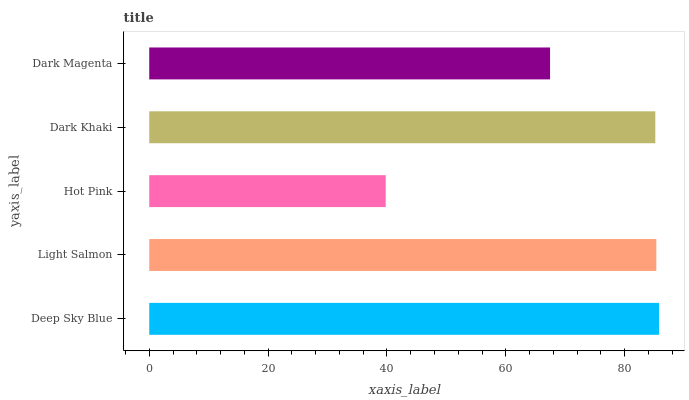Is Hot Pink the minimum?
Answer yes or no. Yes. Is Deep Sky Blue the maximum?
Answer yes or no. Yes. Is Light Salmon the minimum?
Answer yes or no. No. Is Light Salmon the maximum?
Answer yes or no. No. Is Deep Sky Blue greater than Light Salmon?
Answer yes or no. Yes. Is Light Salmon less than Deep Sky Blue?
Answer yes or no. Yes. Is Light Salmon greater than Deep Sky Blue?
Answer yes or no. No. Is Deep Sky Blue less than Light Salmon?
Answer yes or no. No. Is Dark Khaki the high median?
Answer yes or no. Yes. Is Dark Khaki the low median?
Answer yes or no. Yes. Is Dark Magenta the high median?
Answer yes or no. No. Is Deep Sky Blue the low median?
Answer yes or no. No. 